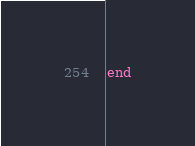<code> <loc_0><loc_0><loc_500><loc_500><_Ruby_>end
</code> 